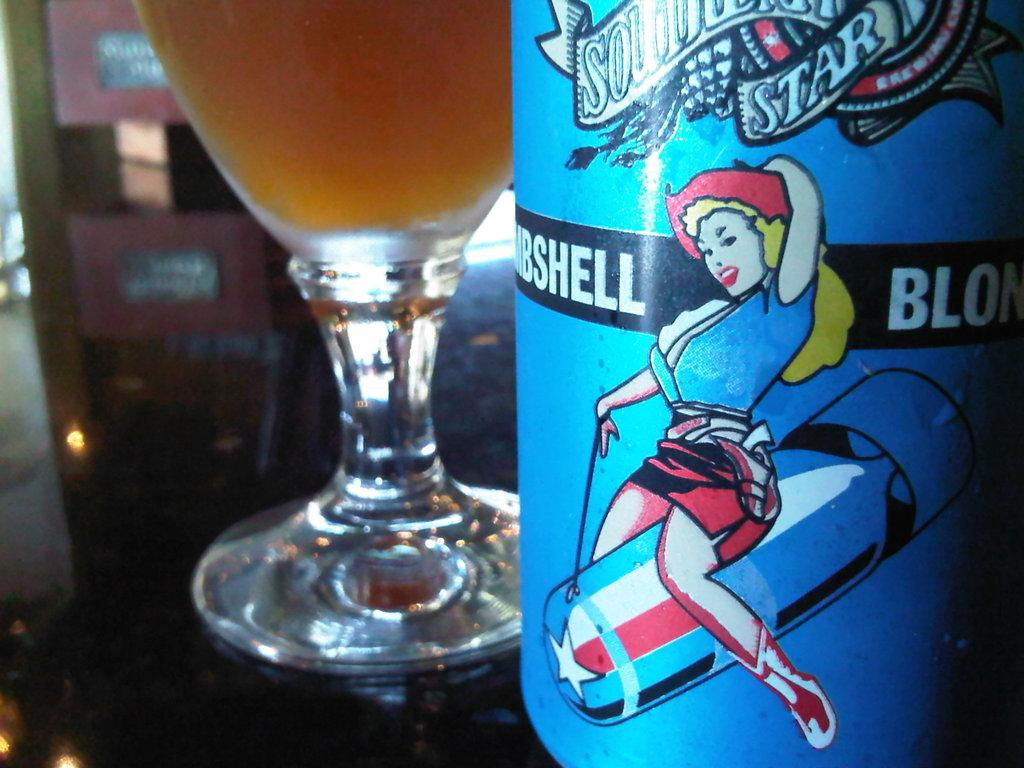<image>
Offer a succinct explanation of the picture presented. A can of Bombshell Blonde has been poured into a glass. 